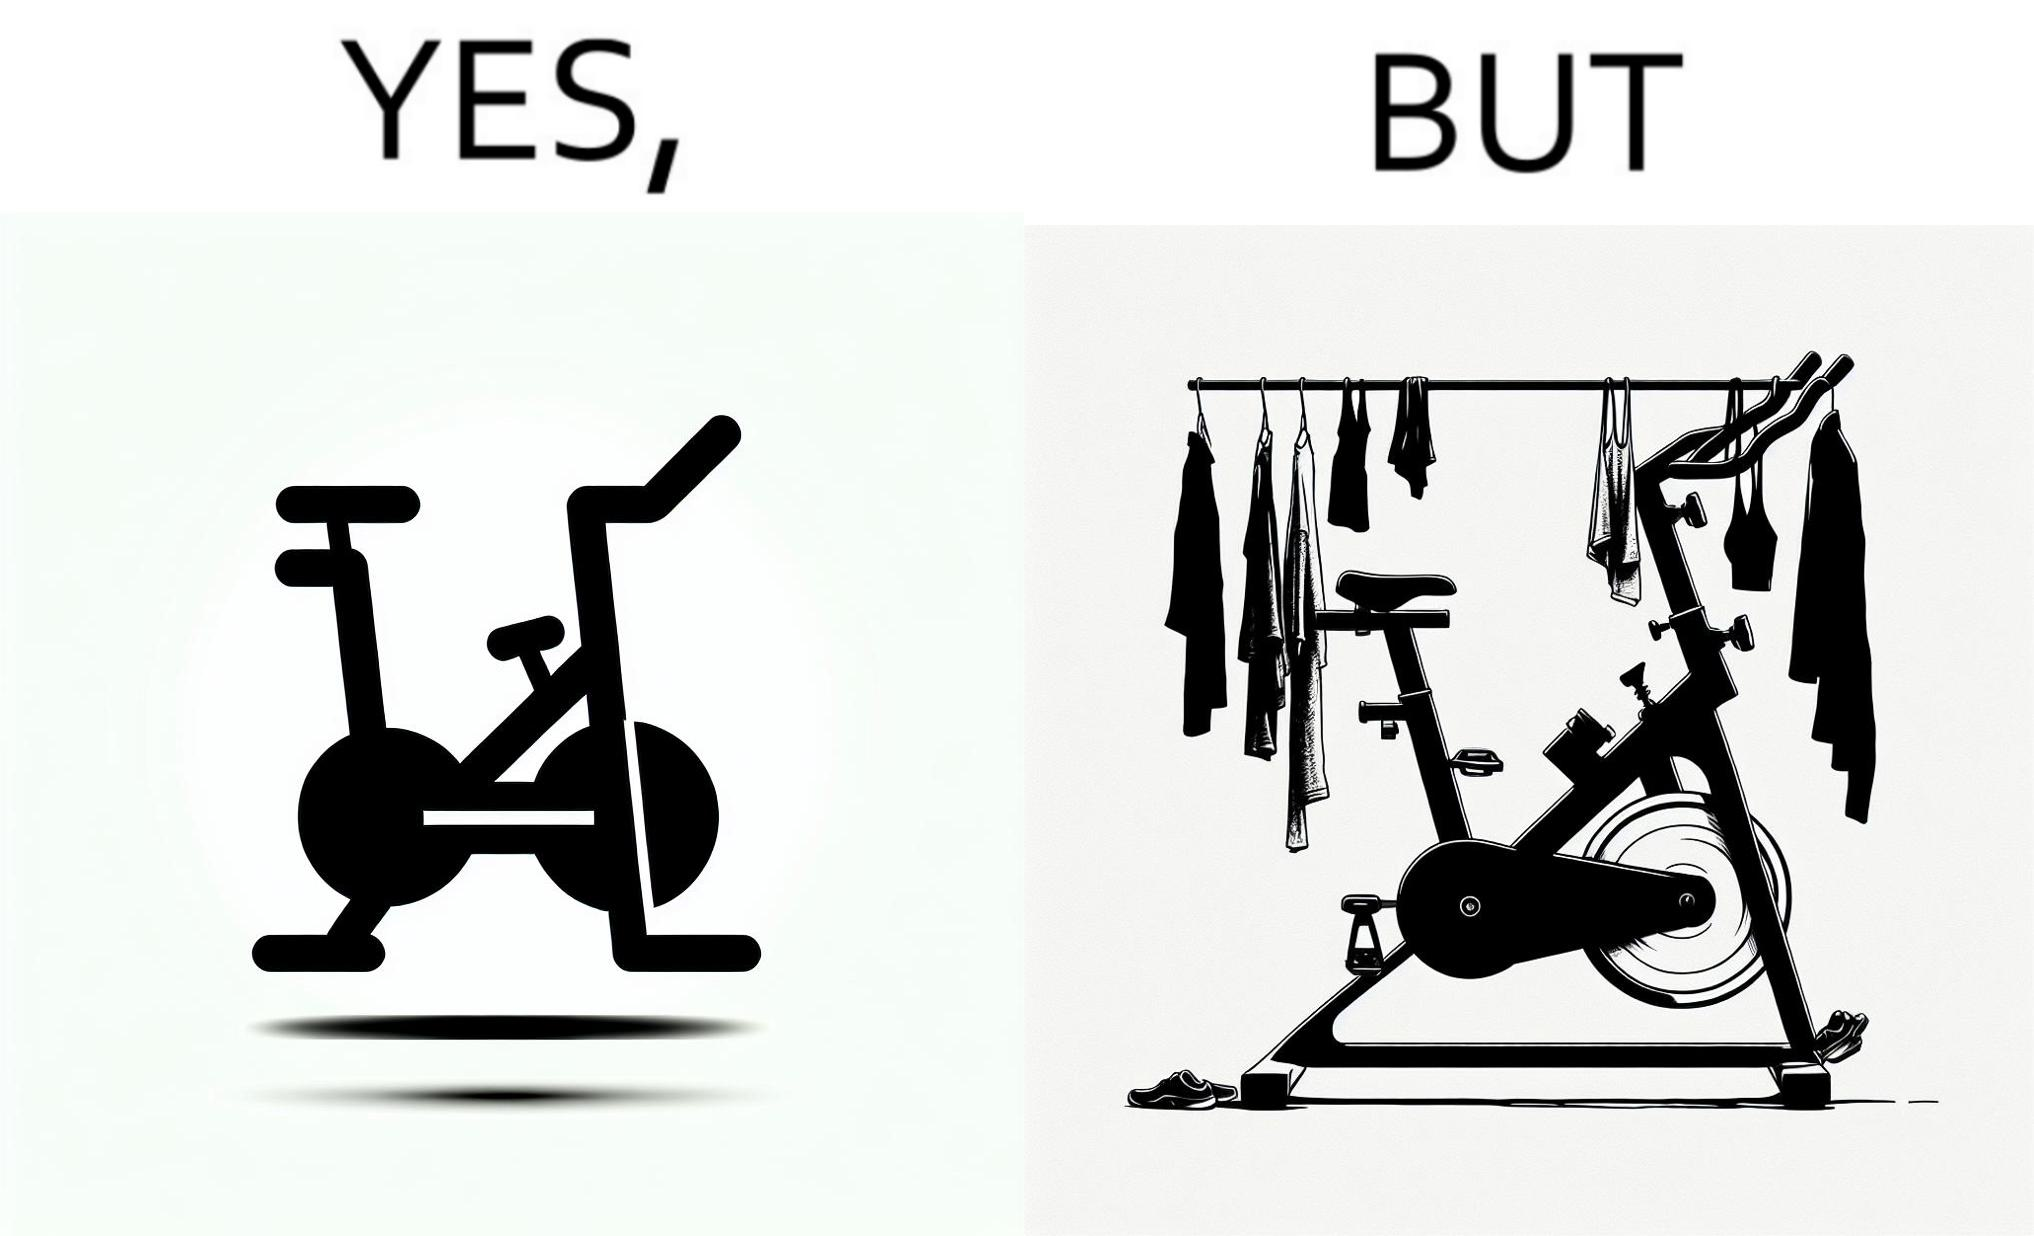Does this image contain satire or humor? Yes, this image is satirical. 